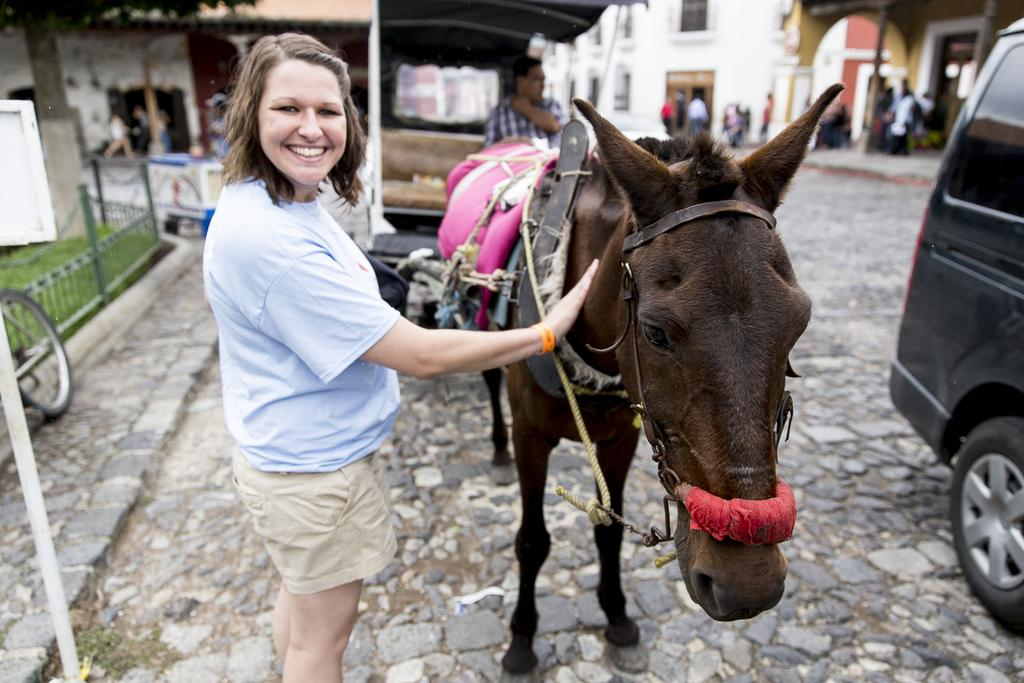What is the woman doing in the image? The woman is standing and smiling in the image. What animal is beside the woman? The woman is beside a donkey. Can you describe the man in the image? There is a man standing in the background of the image. What can be seen in the distance behind the woman and the man? There are buildings visible in the background of the image. What vehicle is on the right side of the image? There is a car on the right side of the image. What type of ship can be seen sailing in the background of the image? There is no ship present in the image; it features a woman, a donkey, a man, buildings, and a car. 